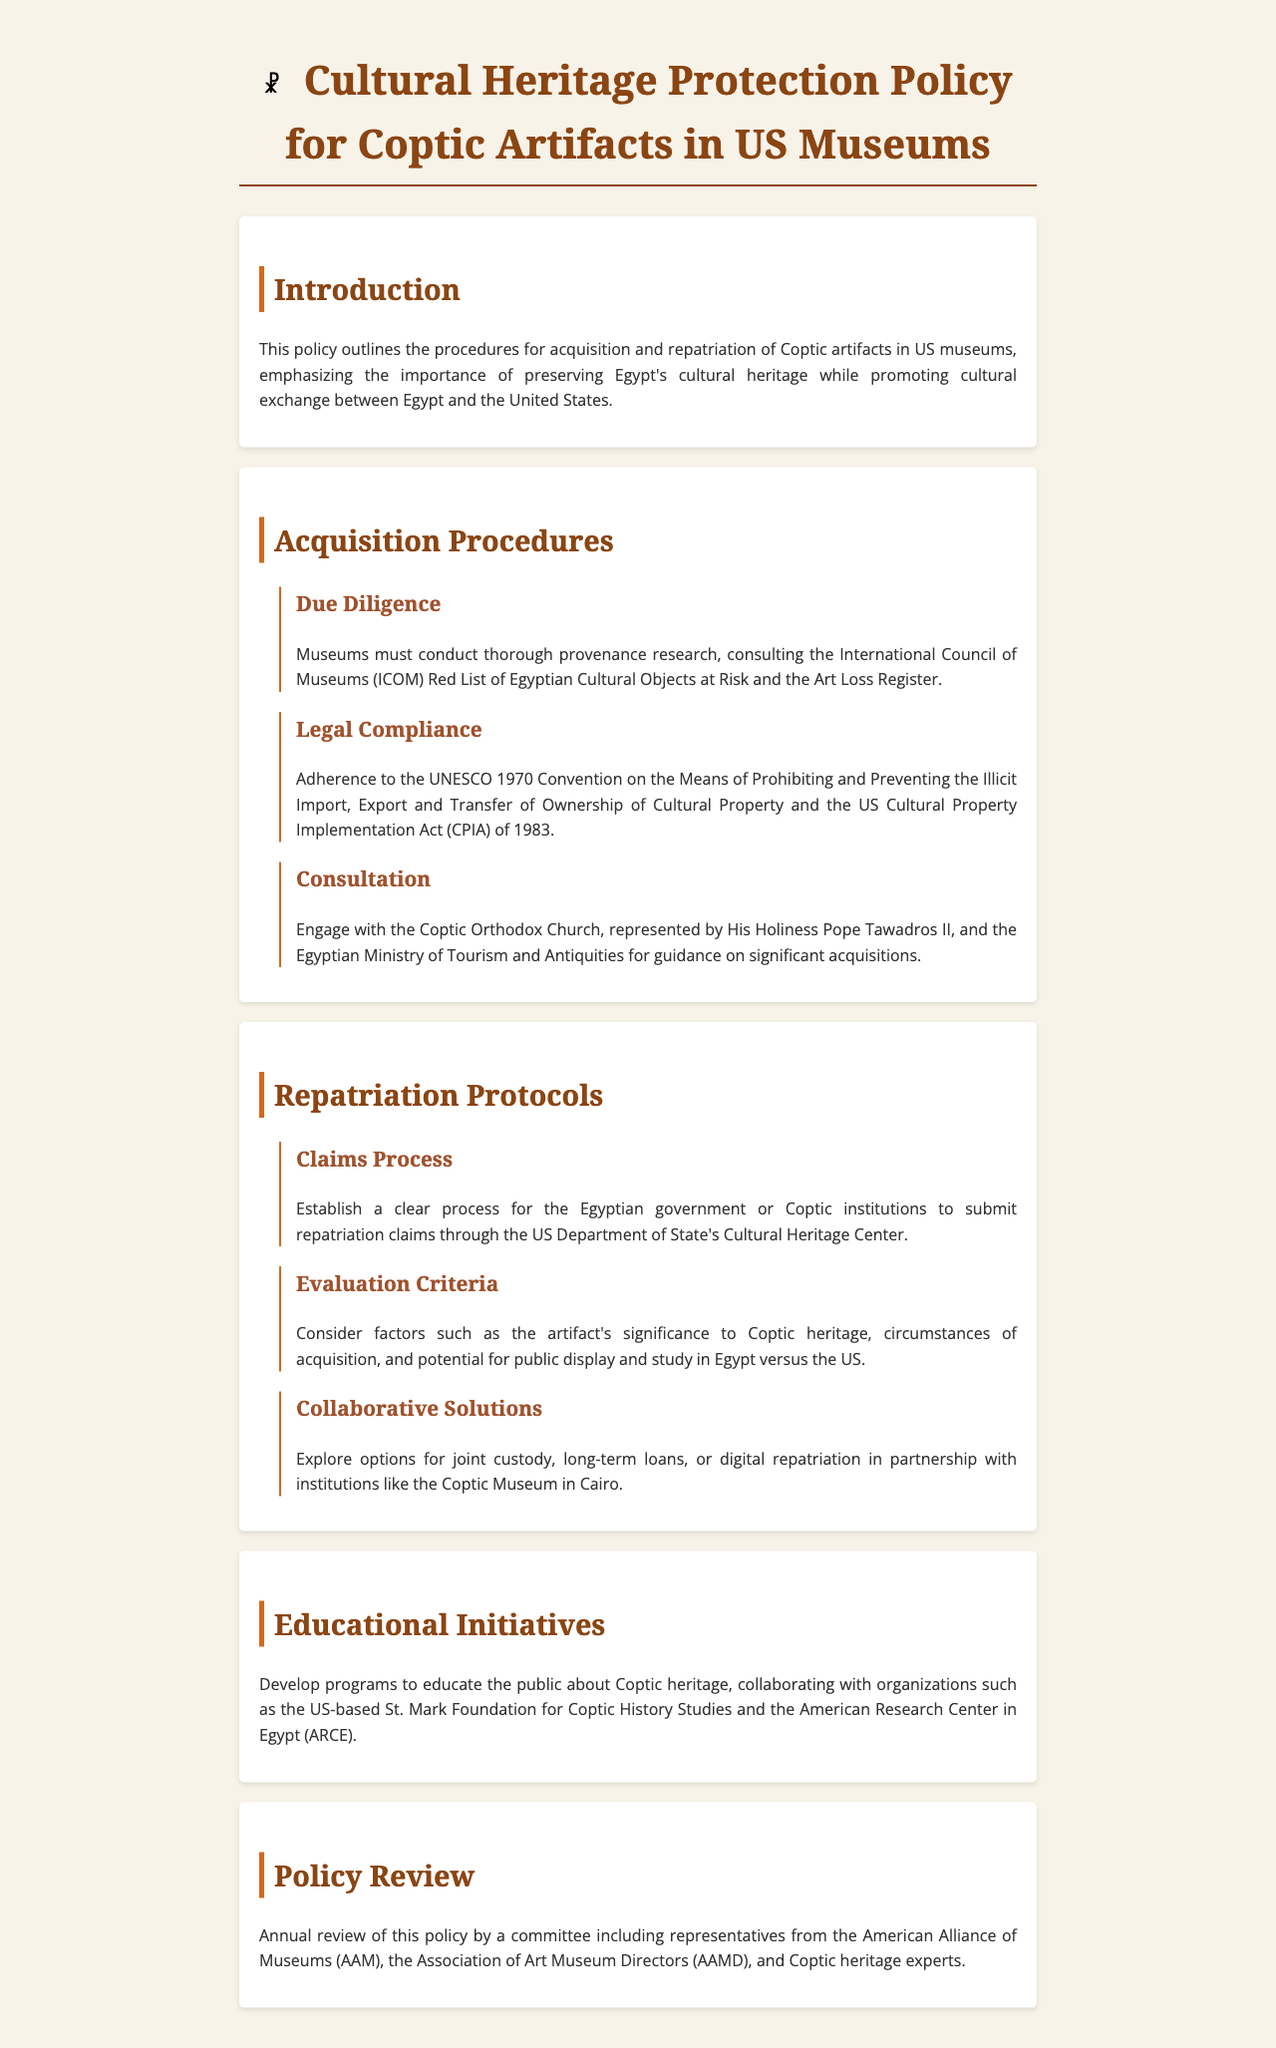What is the title of the policy document? The title of the policy document is stated in the heading of the document.
Answer: Cultural Heritage Protection Policy for Coptic Artifacts in US Museums Who must be consulted during the acquisition procedures? The document outlines that specific organizations should be consulted during the acquisition procedures.
Answer: Coptic Orthodox Church and Egyptian Ministry of Tourism and Antiquities What is the first step in the repatriation protocols? The initial step is detailed in the claims process section of the policies related to repatriation.
Answer: Establish a clear process for claims What criteria should be considered for evaluating repatriation claims? The document specifies factors that need evaluation during the repatriation process.
Answer: Artifact's significance, circumstances of acquisition, public display potential What is the focus of the educational initiatives mentioned? The document states the aim of these initiatives related to Coptic heritage.
Answer: Educate the public about Coptic heritage How often will the policy be reviewed? The frequency of the policy review is mentioned in the document's relevant section.
Answer: Annually 